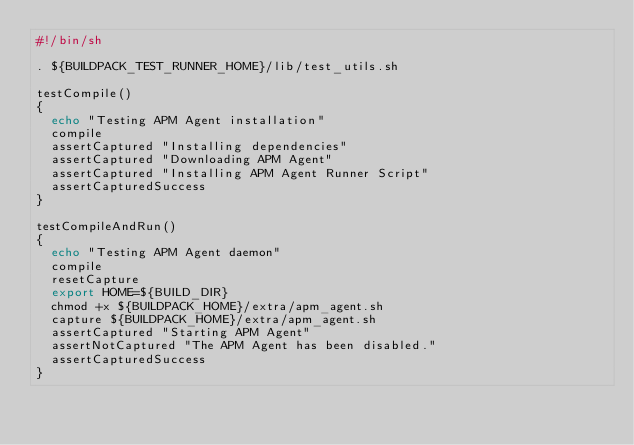<code> <loc_0><loc_0><loc_500><loc_500><_Bash_>#!/bin/sh

. ${BUILDPACK_TEST_RUNNER_HOME}/lib/test_utils.sh

testCompile()
{
  echo "Testing APM Agent installation"
  compile
  assertCaptured "Installing dependencies"
  assertCaptured "Downloading APM Agent"
  assertCaptured "Installing APM Agent Runner Script"
  assertCapturedSuccess
}

testCompileAndRun()
{
  echo "Testing APM Agent daemon"
  compile
  resetCapture
  export HOME=${BUILD_DIR}
  chmod +x ${BUILDPACK_HOME}/extra/apm_agent.sh
  capture ${BUILDPACK_HOME}/extra/apm_agent.sh
  assertCaptured "Starting APM Agent"
  assertNotCaptured "The APM Agent has been disabled."
  assertCapturedSuccess
}</code> 